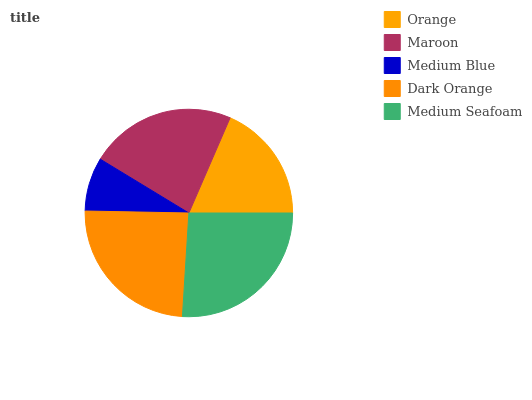Is Medium Blue the minimum?
Answer yes or no. Yes. Is Medium Seafoam the maximum?
Answer yes or no. Yes. Is Maroon the minimum?
Answer yes or no. No. Is Maroon the maximum?
Answer yes or no. No. Is Maroon greater than Orange?
Answer yes or no. Yes. Is Orange less than Maroon?
Answer yes or no. Yes. Is Orange greater than Maroon?
Answer yes or no. No. Is Maroon less than Orange?
Answer yes or no. No. Is Maroon the high median?
Answer yes or no. Yes. Is Maroon the low median?
Answer yes or no. Yes. Is Dark Orange the high median?
Answer yes or no. No. Is Medium Blue the low median?
Answer yes or no. No. 